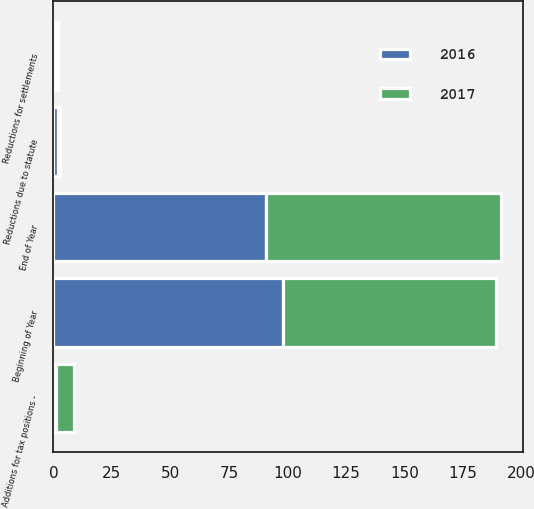Convert chart to OTSL. <chart><loc_0><loc_0><loc_500><loc_500><stacked_bar_chart><ecel><fcel>Beginning of Year<fcel>Additions for tax positions -<fcel>Reductions for settlements<fcel>Reductions due to statute<fcel>End of Year<nl><fcel>2017<fcel>91<fcel>8<fcel>1<fcel>1<fcel>100<nl><fcel>2016<fcel>98<fcel>1<fcel>1<fcel>2<fcel>91<nl></chart> 